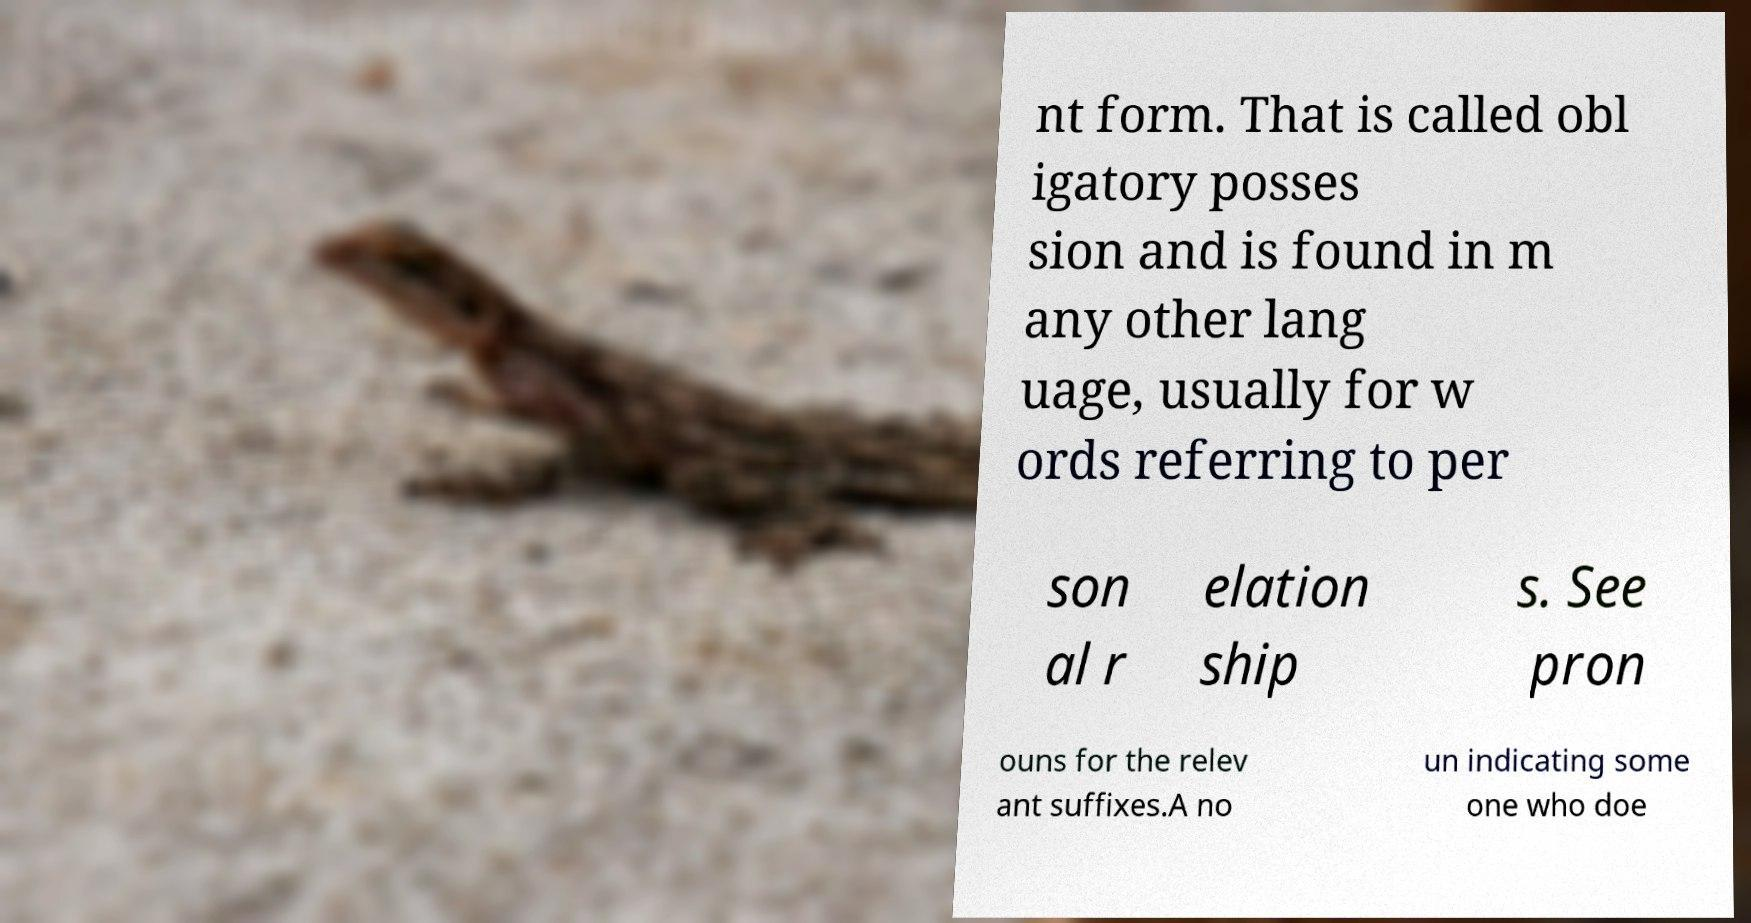Could you extract and type out the text from this image? nt form. That is called obl igatory posses sion and is found in m any other lang uage, usually for w ords referring to per son al r elation ship s. See pron ouns for the relev ant suffixes.A no un indicating some one who doe 